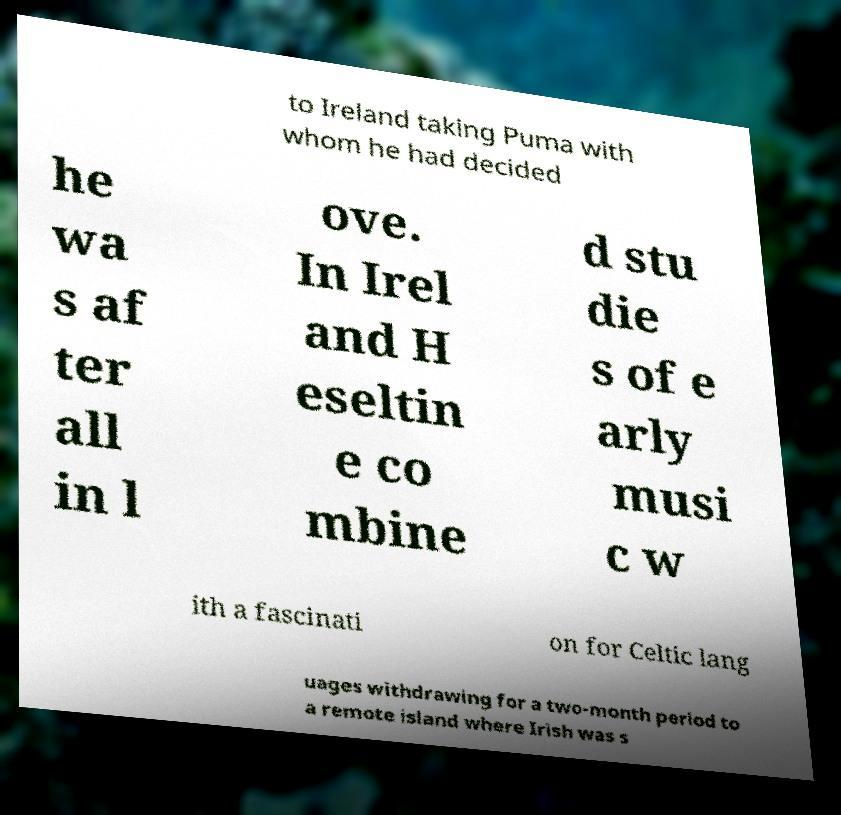Could you assist in decoding the text presented in this image and type it out clearly? to Ireland taking Puma with whom he had decided he wa s af ter all in l ove. In Irel and H eseltin e co mbine d stu die s of e arly musi c w ith a fascinati on for Celtic lang uages withdrawing for a two-month period to a remote island where Irish was s 